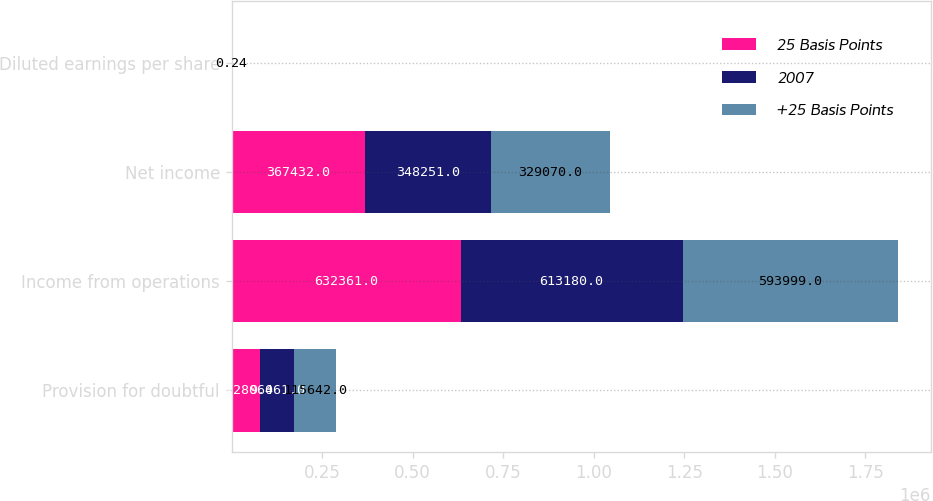Convert chart. <chart><loc_0><loc_0><loc_500><loc_500><stacked_bar_chart><ecel><fcel>Provision for doubtful<fcel>Income from operations<fcel>Net income<fcel>Diluted earnings per share<nl><fcel>25 Basis Points<fcel>77280<fcel>632361<fcel>367432<fcel>0.27<nl><fcel>2007<fcel>96461<fcel>613180<fcel>348251<fcel>0.25<nl><fcel>+25 Basis Points<fcel>115642<fcel>593999<fcel>329070<fcel>0.24<nl></chart> 